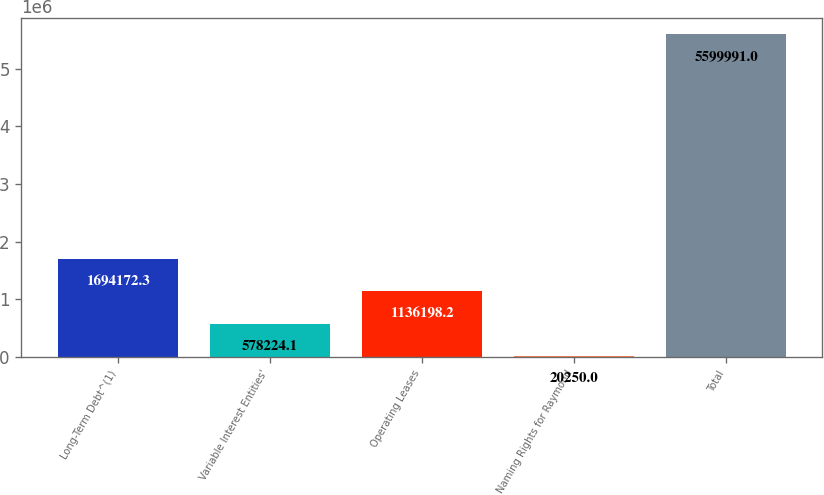<chart> <loc_0><loc_0><loc_500><loc_500><bar_chart><fcel>Long-Term Debt^(1)<fcel>Variable Interest Entities'<fcel>Operating Leases<fcel>Naming Rights for Raymond<fcel>Total<nl><fcel>1.69417e+06<fcel>578224<fcel>1.1362e+06<fcel>20250<fcel>5.59999e+06<nl></chart> 